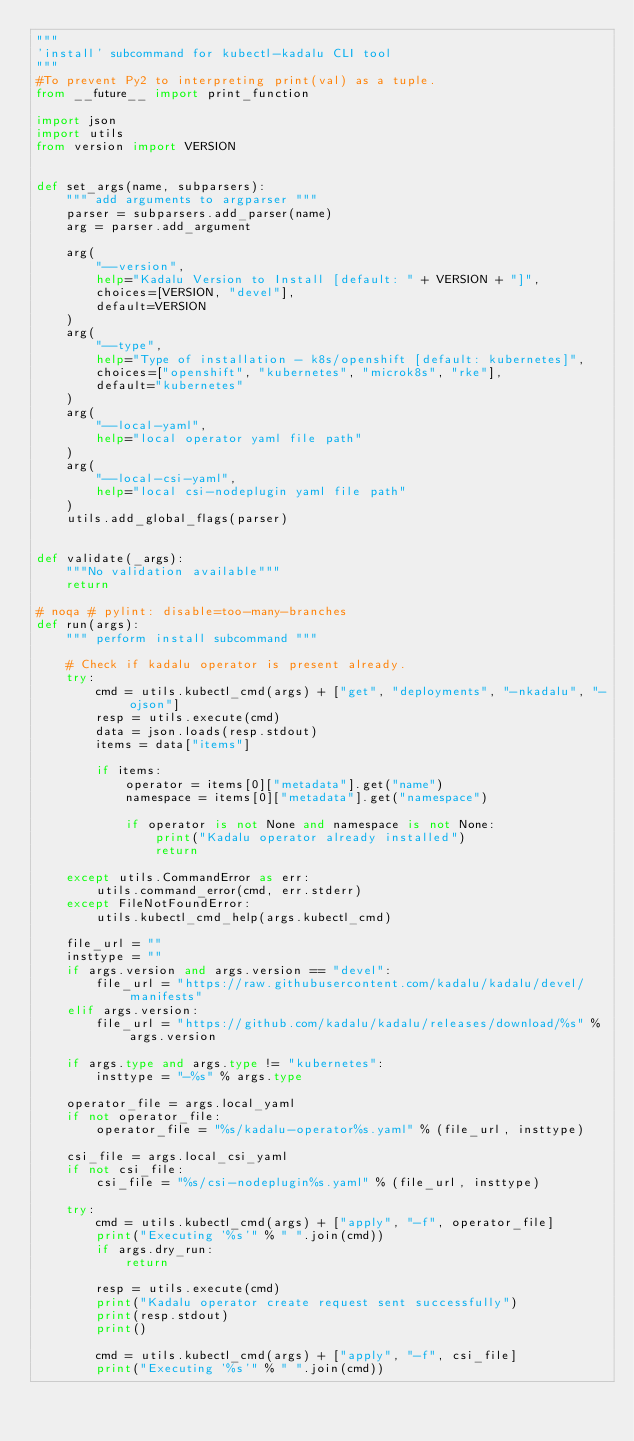Convert code to text. <code><loc_0><loc_0><loc_500><loc_500><_Python_>"""
'install' subcommand for kubectl-kadalu CLI tool
"""
#To prevent Py2 to interpreting print(val) as a tuple.
from __future__ import print_function

import json
import utils
from version import VERSION


def set_args(name, subparsers):
    """ add arguments to argparser """
    parser = subparsers.add_parser(name)
    arg = parser.add_argument

    arg(
        "--version",
        help="Kadalu Version to Install [default: " + VERSION + "]",
        choices=[VERSION, "devel"],
        default=VERSION
    )
    arg(
        "--type",
        help="Type of installation - k8s/openshift [default: kubernetes]",
        choices=["openshift", "kubernetes", "microk8s", "rke"],
        default="kubernetes"
    )
    arg(
        "--local-yaml",
        help="local operator yaml file path"
    )
    arg(
        "--local-csi-yaml",
        help="local csi-nodeplugin yaml file path"
    )
    utils.add_global_flags(parser)


def validate(_args):
    """No validation available"""
    return

# noqa # pylint: disable=too-many-branches
def run(args):
    """ perform install subcommand """

    # Check if kadalu operator is present already.
    try:
        cmd = utils.kubectl_cmd(args) + ["get", "deployments", "-nkadalu", "-ojson"]
        resp = utils.execute(cmd)
        data = json.loads(resp.stdout)
        items = data["items"]

        if items:
            operator = items[0]["metadata"].get("name")
            namespace = items[0]["metadata"].get("namespace")

            if operator is not None and namespace is not None:
                print("Kadalu operator already installed")
                return

    except utils.CommandError as err:
        utils.command_error(cmd, err.stderr)
    except FileNotFoundError:
        utils.kubectl_cmd_help(args.kubectl_cmd)

    file_url = ""
    insttype = ""
    if args.version and args.version == "devel":
        file_url = "https://raw.githubusercontent.com/kadalu/kadalu/devel/manifests"
    elif args.version:
        file_url = "https://github.com/kadalu/kadalu/releases/download/%s" % args.version

    if args.type and args.type != "kubernetes":
        insttype = "-%s" % args.type

    operator_file = args.local_yaml
    if not operator_file:
        operator_file = "%s/kadalu-operator%s.yaml" % (file_url, insttype)

    csi_file = args.local_csi_yaml
    if not csi_file:
        csi_file = "%s/csi-nodeplugin%s.yaml" % (file_url, insttype)

    try:
        cmd = utils.kubectl_cmd(args) + ["apply", "-f", operator_file]
        print("Executing '%s'" % " ".join(cmd))
        if args.dry_run:
            return

        resp = utils.execute(cmd)
        print("Kadalu operator create request sent successfully")
        print(resp.stdout)
        print()

        cmd = utils.kubectl_cmd(args) + ["apply", "-f", csi_file]
        print("Executing '%s'" % " ".join(cmd))</code> 